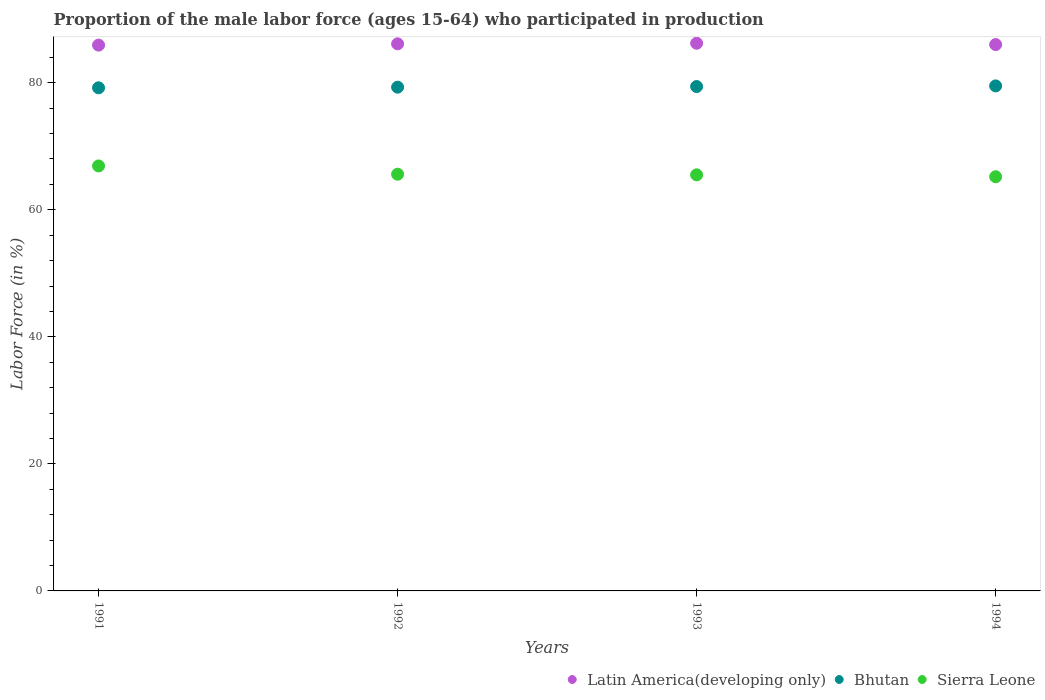Is the number of dotlines equal to the number of legend labels?
Provide a short and direct response. Yes. What is the proportion of the male labor force who participated in production in Bhutan in 1993?
Offer a very short reply. 79.4. Across all years, what is the maximum proportion of the male labor force who participated in production in Sierra Leone?
Offer a terse response. 66.9. Across all years, what is the minimum proportion of the male labor force who participated in production in Sierra Leone?
Ensure brevity in your answer.  65.2. In which year was the proportion of the male labor force who participated in production in Bhutan minimum?
Keep it short and to the point. 1991. What is the total proportion of the male labor force who participated in production in Latin America(developing only) in the graph?
Offer a terse response. 344.27. What is the difference between the proportion of the male labor force who participated in production in Sierra Leone in 1991 and that in 1994?
Offer a very short reply. 1.7. What is the difference between the proportion of the male labor force who participated in production in Sierra Leone in 1993 and the proportion of the male labor force who participated in production in Latin America(developing only) in 1994?
Provide a short and direct response. -20.51. What is the average proportion of the male labor force who participated in production in Sierra Leone per year?
Make the answer very short. 65.8. In the year 1994, what is the difference between the proportion of the male labor force who participated in production in Latin America(developing only) and proportion of the male labor force who participated in production in Bhutan?
Give a very brief answer. 6.51. In how many years, is the proportion of the male labor force who participated in production in Bhutan greater than 16 %?
Provide a short and direct response. 4. What is the ratio of the proportion of the male labor force who participated in production in Latin America(developing only) in 1991 to that in 1992?
Your response must be concise. 1. Is the difference between the proportion of the male labor force who participated in production in Latin America(developing only) in 1992 and 1993 greater than the difference between the proportion of the male labor force who participated in production in Bhutan in 1992 and 1993?
Provide a short and direct response. Yes. What is the difference between the highest and the second highest proportion of the male labor force who participated in production in Sierra Leone?
Your answer should be compact. 1.3. What is the difference between the highest and the lowest proportion of the male labor force who participated in production in Bhutan?
Provide a short and direct response. 0.3. In how many years, is the proportion of the male labor force who participated in production in Bhutan greater than the average proportion of the male labor force who participated in production in Bhutan taken over all years?
Keep it short and to the point. 2. Is the proportion of the male labor force who participated in production in Latin America(developing only) strictly greater than the proportion of the male labor force who participated in production in Sierra Leone over the years?
Make the answer very short. Yes. Is the proportion of the male labor force who participated in production in Sierra Leone strictly less than the proportion of the male labor force who participated in production in Latin America(developing only) over the years?
Give a very brief answer. Yes. How many dotlines are there?
Your answer should be compact. 3. Are the values on the major ticks of Y-axis written in scientific E-notation?
Offer a very short reply. No. Does the graph contain any zero values?
Provide a short and direct response. No. How many legend labels are there?
Your answer should be very brief. 3. What is the title of the graph?
Your answer should be compact. Proportion of the male labor force (ages 15-64) who participated in production. Does "Suriname" appear as one of the legend labels in the graph?
Offer a very short reply. No. What is the Labor Force (in %) in Latin America(developing only) in 1991?
Make the answer very short. 85.92. What is the Labor Force (in %) of Bhutan in 1991?
Provide a short and direct response. 79.2. What is the Labor Force (in %) of Sierra Leone in 1991?
Give a very brief answer. 66.9. What is the Labor Force (in %) of Latin America(developing only) in 1992?
Offer a very short reply. 86.12. What is the Labor Force (in %) of Bhutan in 1992?
Keep it short and to the point. 79.3. What is the Labor Force (in %) in Sierra Leone in 1992?
Give a very brief answer. 65.6. What is the Labor Force (in %) in Latin America(developing only) in 1993?
Provide a succinct answer. 86.21. What is the Labor Force (in %) of Bhutan in 1993?
Make the answer very short. 79.4. What is the Labor Force (in %) of Sierra Leone in 1993?
Provide a short and direct response. 65.5. What is the Labor Force (in %) in Latin America(developing only) in 1994?
Your answer should be very brief. 86.01. What is the Labor Force (in %) of Bhutan in 1994?
Ensure brevity in your answer.  79.5. What is the Labor Force (in %) of Sierra Leone in 1994?
Your answer should be compact. 65.2. Across all years, what is the maximum Labor Force (in %) of Latin America(developing only)?
Ensure brevity in your answer.  86.21. Across all years, what is the maximum Labor Force (in %) of Bhutan?
Keep it short and to the point. 79.5. Across all years, what is the maximum Labor Force (in %) of Sierra Leone?
Ensure brevity in your answer.  66.9. Across all years, what is the minimum Labor Force (in %) in Latin America(developing only)?
Your answer should be very brief. 85.92. Across all years, what is the minimum Labor Force (in %) of Bhutan?
Keep it short and to the point. 79.2. Across all years, what is the minimum Labor Force (in %) in Sierra Leone?
Your answer should be very brief. 65.2. What is the total Labor Force (in %) of Latin America(developing only) in the graph?
Your response must be concise. 344.27. What is the total Labor Force (in %) in Bhutan in the graph?
Your answer should be very brief. 317.4. What is the total Labor Force (in %) of Sierra Leone in the graph?
Your response must be concise. 263.2. What is the difference between the Labor Force (in %) of Latin America(developing only) in 1991 and that in 1992?
Offer a very short reply. -0.2. What is the difference between the Labor Force (in %) in Bhutan in 1991 and that in 1992?
Ensure brevity in your answer.  -0.1. What is the difference between the Labor Force (in %) in Sierra Leone in 1991 and that in 1992?
Offer a very short reply. 1.3. What is the difference between the Labor Force (in %) of Latin America(developing only) in 1991 and that in 1993?
Your response must be concise. -0.29. What is the difference between the Labor Force (in %) in Bhutan in 1991 and that in 1993?
Your response must be concise. -0.2. What is the difference between the Labor Force (in %) in Sierra Leone in 1991 and that in 1993?
Provide a succinct answer. 1.4. What is the difference between the Labor Force (in %) of Latin America(developing only) in 1991 and that in 1994?
Make the answer very short. -0.09. What is the difference between the Labor Force (in %) of Bhutan in 1991 and that in 1994?
Your answer should be very brief. -0.3. What is the difference between the Labor Force (in %) in Sierra Leone in 1991 and that in 1994?
Keep it short and to the point. 1.7. What is the difference between the Labor Force (in %) of Latin America(developing only) in 1992 and that in 1993?
Your answer should be compact. -0.09. What is the difference between the Labor Force (in %) in Bhutan in 1992 and that in 1993?
Your answer should be very brief. -0.1. What is the difference between the Labor Force (in %) in Sierra Leone in 1992 and that in 1993?
Your answer should be very brief. 0.1. What is the difference between the Labor Force (in %) of Latin America(developing only) in 1992 and that in 1994?
Keep it short and to the point. 0.12. What is the difference between the Labor Force (in %) of Sierra Leone in 1992 and that in 1994?
Make the answer very short. 0.4. What is the difference between the Labor Force (in %) in Latin America(developing only) in 1993 and that in 1994?
Your response must be concise. 0.21. What is the difference between the Labor Force (in %) in Bhutan in 1993 and that in 1994?
Ensure brevity in your answer.  -0.1. What is the difference between the Labor Force (in %) of Latin America(developing only) in 1991 and the Labor Force (in %) of Bhutan in 1992?
Provide a short and direct response. 6.62. What is the difference between the Labor Force (in %) of Latin America(developing only) in 1991 and the Labor Force (in %) of Sierra Leone in 1992?
Ensure brevity in your answer.  20.32. What is the difference between the Labor Force (in %) in Bhutan in 1991 and the Labor Force (in %) in Sierra Leone in 1992?
Offer a terse response. 13.6. What is the difference between the Labor Force (in %) of Latin America(developing only) in 1991 and the Labor Force (in %) of Bhutan in 1993?
Keep it short and to the point. 6.52. What is the difference between the Labor Force (in %) of Latin America(developing only) in 1991 and the Labor Force (in %) of Sierra Leone in 1993?
Make the answer very short. 20.42. What is the difference between the Labor Force (in %) in Bhutan in 1991 and the Labor Force (in %) in Sierra Leone in 1993?
Your response must be concise. 13.7. What is the difference between the Labor Force (in %) of Latin America(developing only) in 1991 and the Labor Force (in %) of Bhutan in 1994?
Make the answer very short. 6.42. What is the difference between the Labor Force (in %) of Latin America(developing only) in 1991 and the Labor Force (in %) of Sierra Leone in 1994?
Offer a very short reply. 20.72. What is the difference between the Labor Force (in %) of Bhutan in 1991 and the Labor Force (in %) of Sierra Leone in 1994?
Keep it short and to the point. 14. What is the difference between the Labor Force (in %) of Latin America(developing only) in 1992 and the Labor Force (in %) of Bhutan in 1993?
Offer a very short reply. 6.72. What is the difference between the Labor Force (in %) in Latin America(developing only) in 1992 and the Labor Force (in %) in Sierra Leone in 1993?
Provide a short and direct response. 20.62. What is the difference between the Labor Force (in %) of Latin America(developing only) in 1992 and the Labor Force (in %) of Bhutan in 1994?
Offer a terse response. 6.62. What is the difference between the Labor Force (in %) of Latin America(developing only) in 1992 and the Labor Force (in %) of Sierra Leone in 1994?
Offer a terse response. 20.92. What is the difference between the Labor Force (in %) in Latin America(developing only) in 1993 and the Labor Force (in %) in Bhutan in 1994?
Your answer should be compact. 6.71. What is the difference between the Labor Force (in %) of Latin America(developing only) in 1993 and the Labor Force (in %) of Sierra Leone in 1994?
Your response must be concise. 21.01. What is the difference between the Labor Force (in %) in Bhutan in 1993 and the Labor Force (in %) in Sierra Leone in 1994?
Keep it short and to the point. 14.2. What is the average Labor Force (in %) in Latin America(developing only) per year?
Provide a short and direct response. 86.07. What is the average Labor Force (in %) of Bhutan per year?
Your answer should be very brief. 79.35. What is the average Labor Force (in %) in Sierra Leone per year?
Offer a terse response. 65.8. In the year 1991, what is the difference between the Labor Force (in %) in Latin America(developing only) and Labor Force (in %) in Bhutan?
Provide a succinct answer. 6.72. In the year 1991, what is the difference between the Labor Force (in %) of Latin America(developing only) and Labor Force (in %) of Sierra Leone?
Offer a terse response. 19.02. In the year 1991, what is the difference between the Labor Force (in %) in Bhutan and Labor Force (in %) in Sierra Leone?
Keep it short and to the point. 12.3. In the year 1992, what is the difference between the Labor Force (in %) of Latin America(developing only) and Labor Force (in %) of Bhutan?
Offer a terse response. 6.82. In the year 1992, what is the difference between the Labor Force (in %) in Latin America(developing only) and Labor Force (in %) in Sierra Leone?
Give a very brief answer. 20.52. In the year 1993, what is the difference between the Labor Force (in %) in Latin America(developing only) and Labor Force (in %) in Bhutan?
Your answer should be very brief. 6.81. In the year 1993, what is the difference between the Labor Force (in %) in Latin America(developing only) and Labor Force (in %) in Sierra Leone?
Your response must be concise. 20.71. In the year 1993, what is the difference between the Labor Force (in %) in Bhutan and Labor Force (in %) in Sierra Leone?
Offer a very short reply. 13.9. In the year 1994, what is the difference between the Labor Force (in %) of Latin America(developing only) and Labor Force (in %) of Bhutan?
Your answer should be very brief. 6.51. In the year 1994, what is the difference between the Labor Force (in %) of Latin America(developing only) and Labor Force (in %) of Sierra Leone?
Provide a succinct answer. 20.81. In the year 1994, what is the difference between the Labor Force (in %) in Bhutan and Labor Force (in %) in Sierra Leone?
Your response must be concise. 14.3. What is the ratio of the Labor Force (in %) of Bhutan in 1991 to that in 1992?
Keep it short and to the point. 1. What is the ratio of the Labor Force (in %) of Sierra Leone in 1991 to that in 1992?
Give a very brief answer. 1.02. What is the ratio of the Labor Force (in %) in Sierra Leone in 1991 to that in 1993?
Offer a terse response. 1.02. What is the ratio of the Labor Force (in %) in Bhutan in 1991 to that in 1994?
Your answer should be compact. 1. What is the ratio of the Labor Force (in %) in Sierra Leone in 1991 to that in 1994?
Your answer should be compact. 1.03. What is the ratio of the Labor Force (in %) in Sierra Leone in 1992 to that in 1993?
Ensure brevity in your answer.  1. What is the ratio of the Labor Force (in %) in Latin America(developing only) in 1992 to that in 1994?
Give a very brief answer. 1. What is the ratio of the Labor Force (in %) in Bhutan in 1992 to that in 1994?
Your response must be concise. 1. What is the ratio of the Labor Force (in %) of Bhutan in 1993 to that in 1994?
Ensure brevity in your answer.  1. What is the difference between the highest and the second highest Labor Force (in %) of Latin America(developing only)?
Provide a succinct answer. 0.09. What is the difference between the highest and the second highest Labor Force (in %) of Sierra Leone?
Your answer should be very brief. 1.3. What is the difference between the highest and the lowest Labor Force (in %) in Latin America(developing only)?
Make the answer very short. 0.29. What is the difference between the highest and the lowest Labor Force (in %) in Bhutan?
Offer a very short reply. 0.3. What is the difference between the highest and the lowest Labor Force (in %) in Sierra Leone?
Offer a terse response. 1.7. 